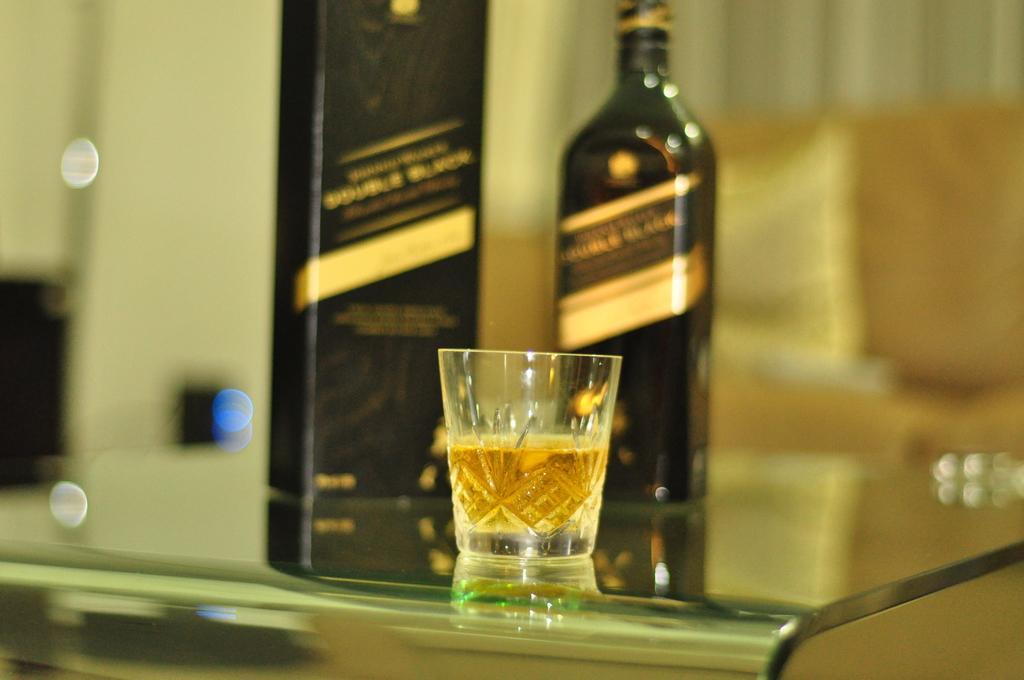Could you give a brief overview of what you see in this image? In this image, I can see a glass with alcohol, bottle and a box, which are on a glass table. There is a blurred background. 